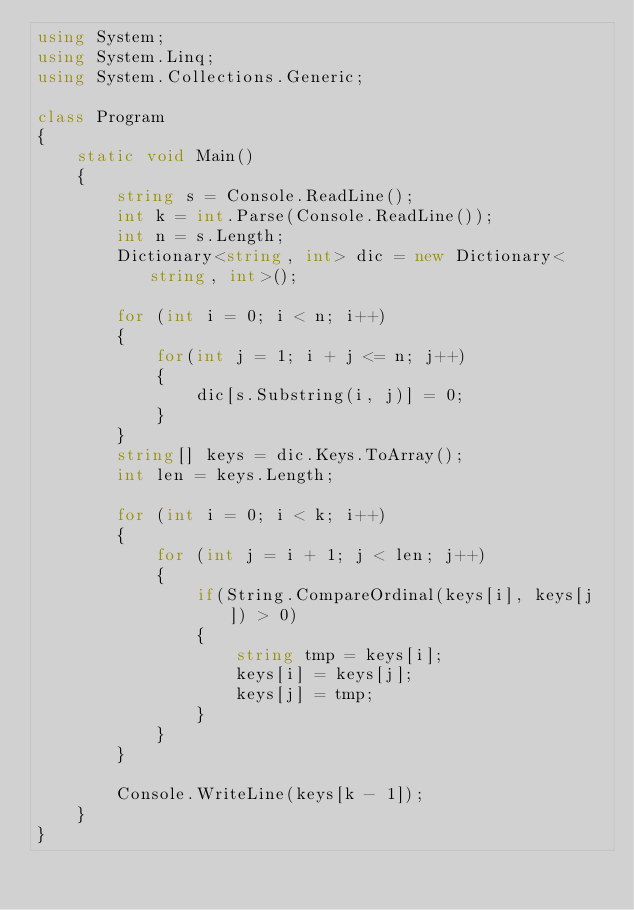<code> <loc_0><loc_0><loc_500><loc_500><_C#_>using System;
using System.Linq;
using System.Collections.Generic;

class Program
{
    static void Main()
    {
        string s = Console.ReadLine();
        int k = int.Parse(Console.ReadLine());
        int n = s.Length;
        Dictionary<string, int> dic = new Dictionary<string, int>();

        for (int i = 0; i < n; i++)
        {
            for(int j = 1; i + j <= n; j++)
            {
                dic[s.Substring(i, j)] = 0;
            }
        }
        string[] keys = dic.Keys.ToArray();
        int len = keys.Length;

        for (int i = 0; i < k; i++)
        {
            for (int j = i + 1; j < len; j++)
            {
                if(String.CompareOrdinal(keys[i], keys[j]) > 0)
                {
                    string tmp = keys[i];
                    keys[i] = keys[j];
                    keys[j] = tmp;
                }
            }
        }

        Console.WriteLine(keys[k - 1]);
    }
}</code> 